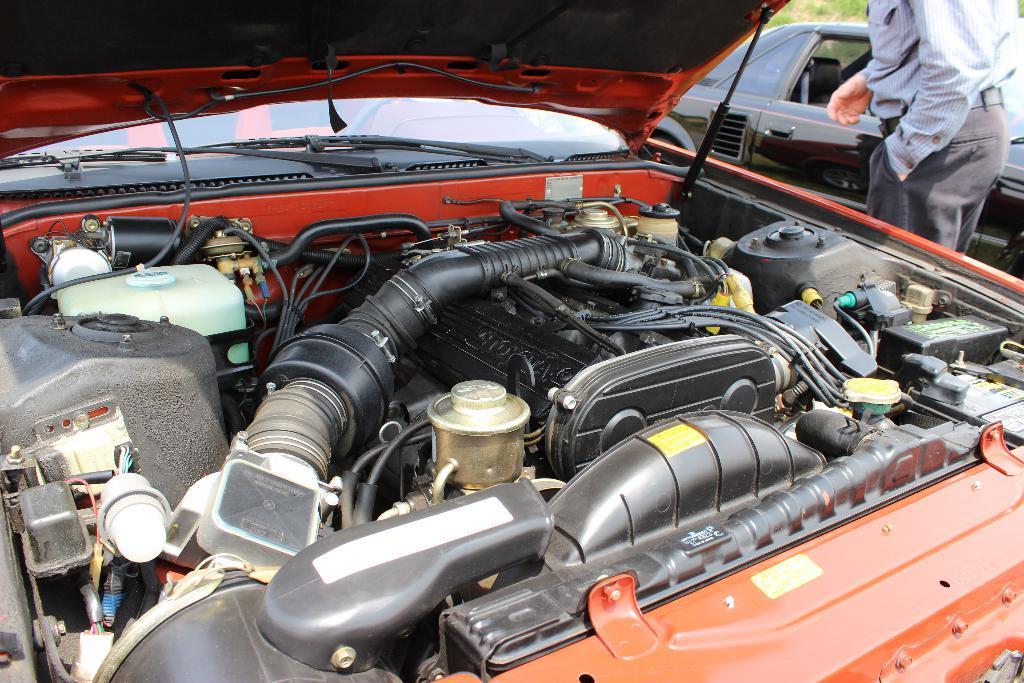Please provide a concise description of this image. In this image we can see bonnet of an orange color car is open. In the right top of the image, one person and black color car is there. The person is wearing a shirt and black pant. 